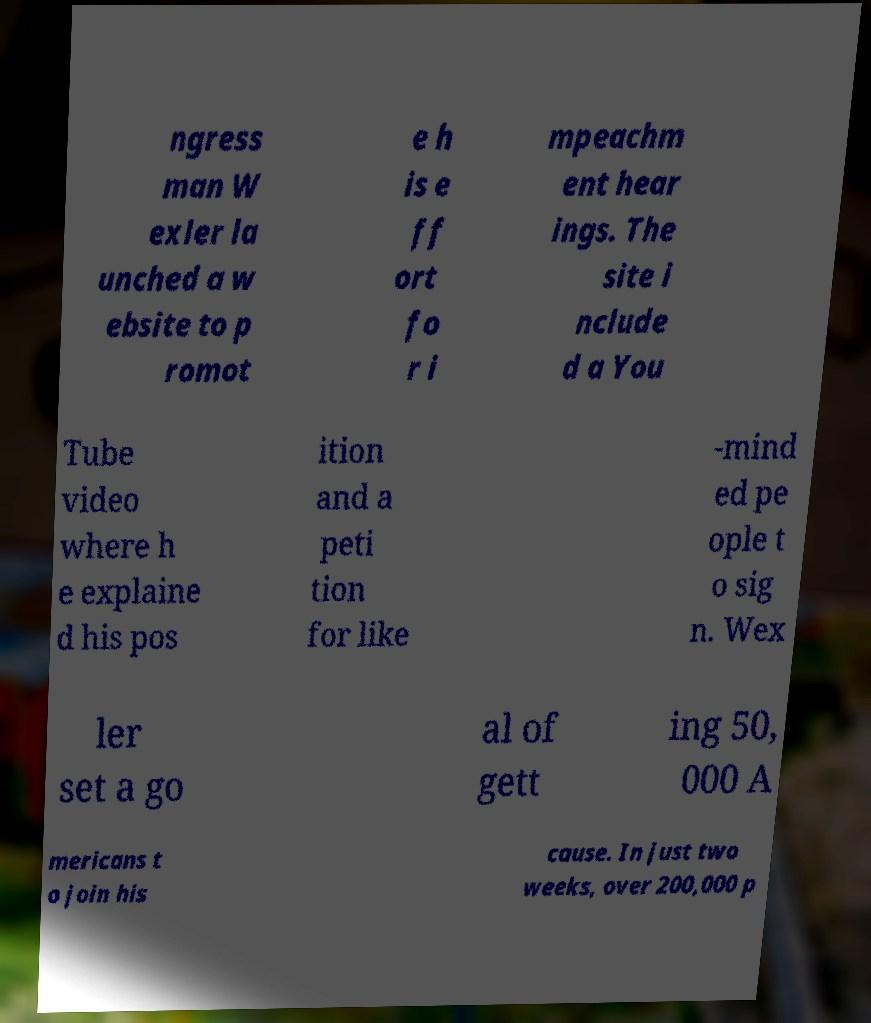What messages or text are displayed in this image? I need them in a readable, typed format. ngress man W exler la unched a w ebsite to p romot e h is e ff ort fo r i mpeachm ent hear ings. The site i nclude d a You Tube video where h e explaine d his pos ition and a peti tion for like -mind ed pe ople t o sig n. Wex ler set a go al of gett ing 50, 000 A mericans t o join his cause. In just two weeks, over 200,000 p 